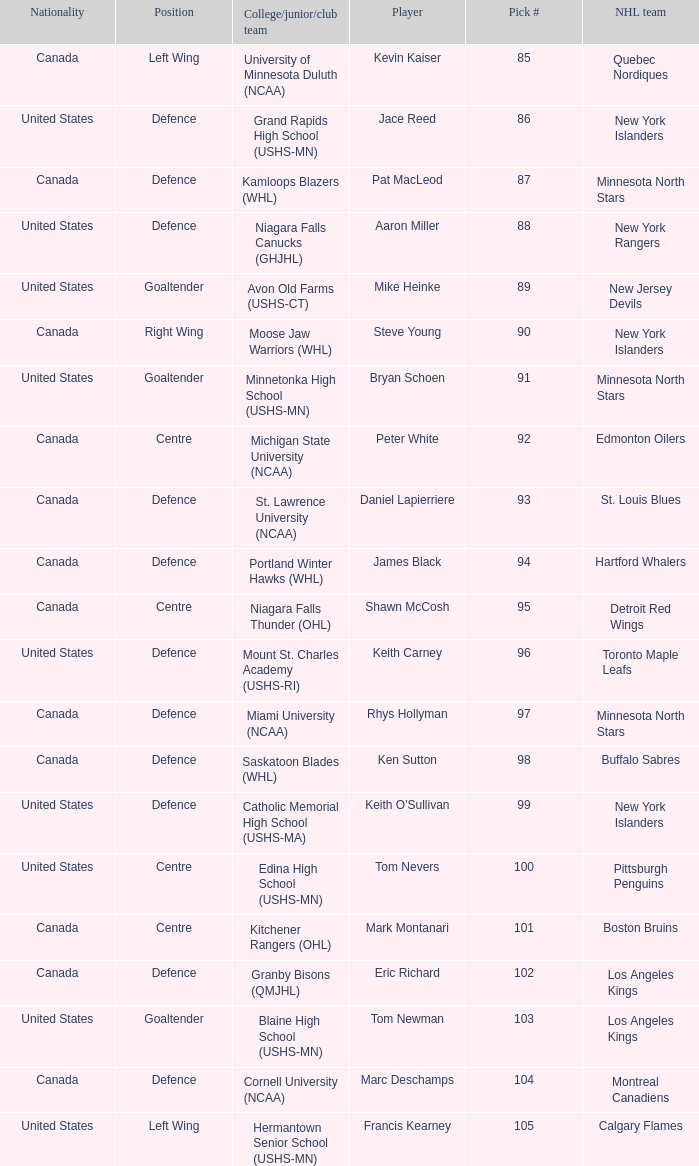What selection number was marc deschamps? 104.0. 